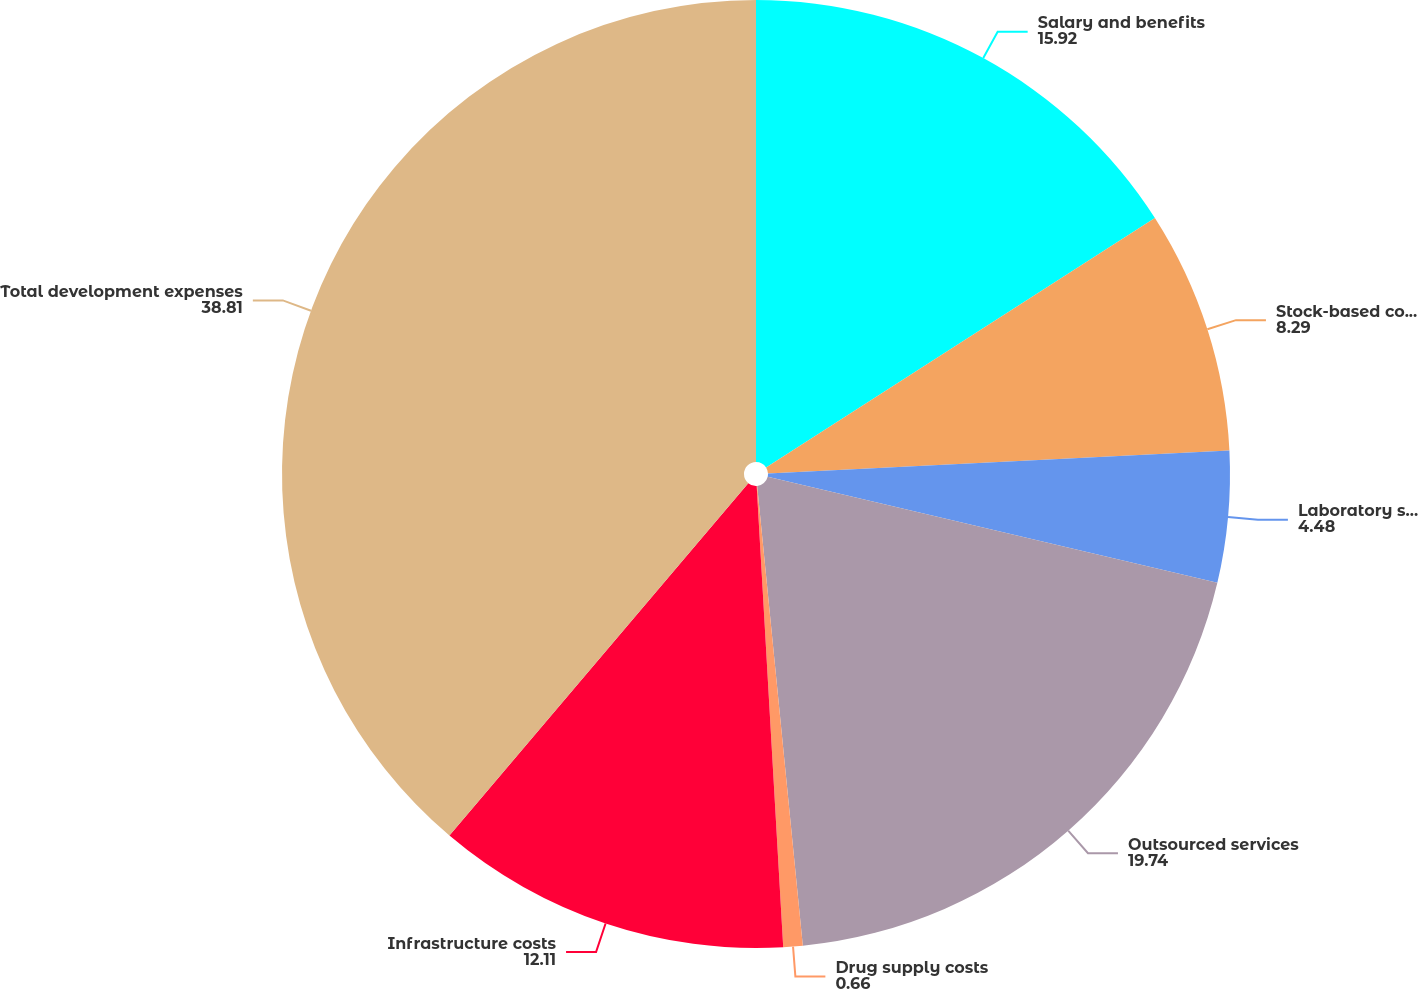Convert chart to OTSL. <chart><loc_0><loc_0><loc_500><loc_500><pie_chart><fcel>Salary and benefits<fcel>Stock-based compensation<fcel>Laboratory supplies and other<fcel>Outsourced services<fcel>Drug supply costs<fcel>Infrastructure costs<fcel>Total development expenses<nl><fcel>15.92%<fcel>8.29%<fcel>4.48%<fcel>19.74%<fcel>0.66%<fcel>12.11%<fcel>38.81%<nl></chart> 